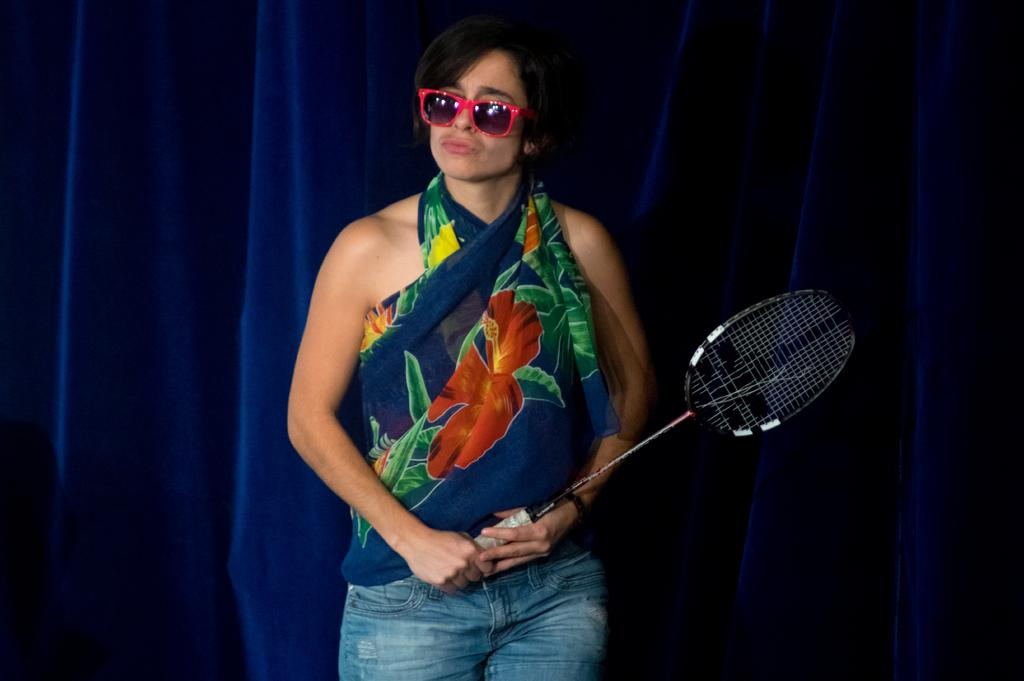Who is the main subject in the image? There is a woman in the image. What is the woman holding in the image? The woman is holding a badminton racket. What accessory is the woman wearing in the image? The woman is wearing sunglasses. What type of window treatment is visible in the image? There is a curtain visible in the image. What type of magic trick is the woman performing in the image? There is no indication of a magic trick being performed in the image; the woman is simply holding a badminton racket. 